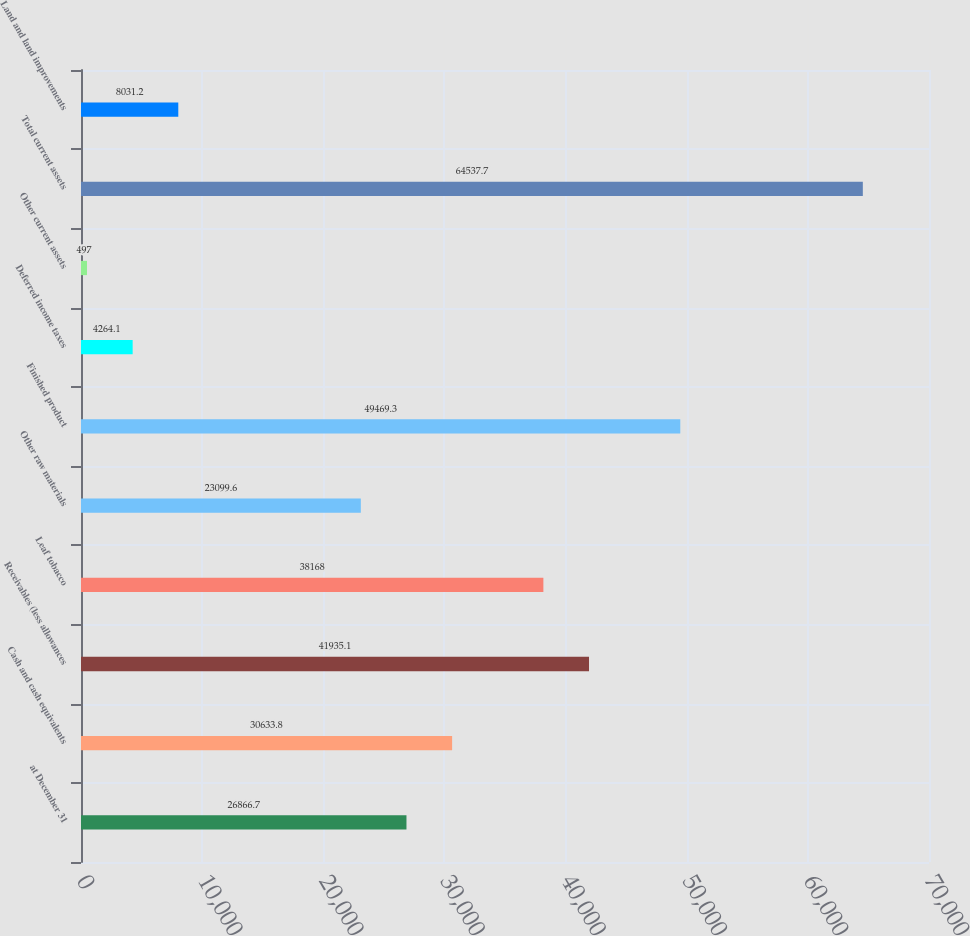Convert chart. <chart><loc_0><loc_0><loc_500><loc_500><bar_chart><fcel>at December 31<fcel>Cash and cash equivalents<fcel>Receivables (less allowances<fcel>Leaf tobacco<fcel>Other raw materials<fcel>Finished product<fcel>Deferred income taxes<fcel>Other current assets<fcel>Total current assets<fcel>Land and land improvements<nl><fcel>26866.7<fcel>30633.8<fcel>41935.1<fcel>38168<fcel>23099.6<fcel>49469.3<fcel>4264.1<fcel>497<fcel>64537.7<fcel>8031.2<nl></chart> 